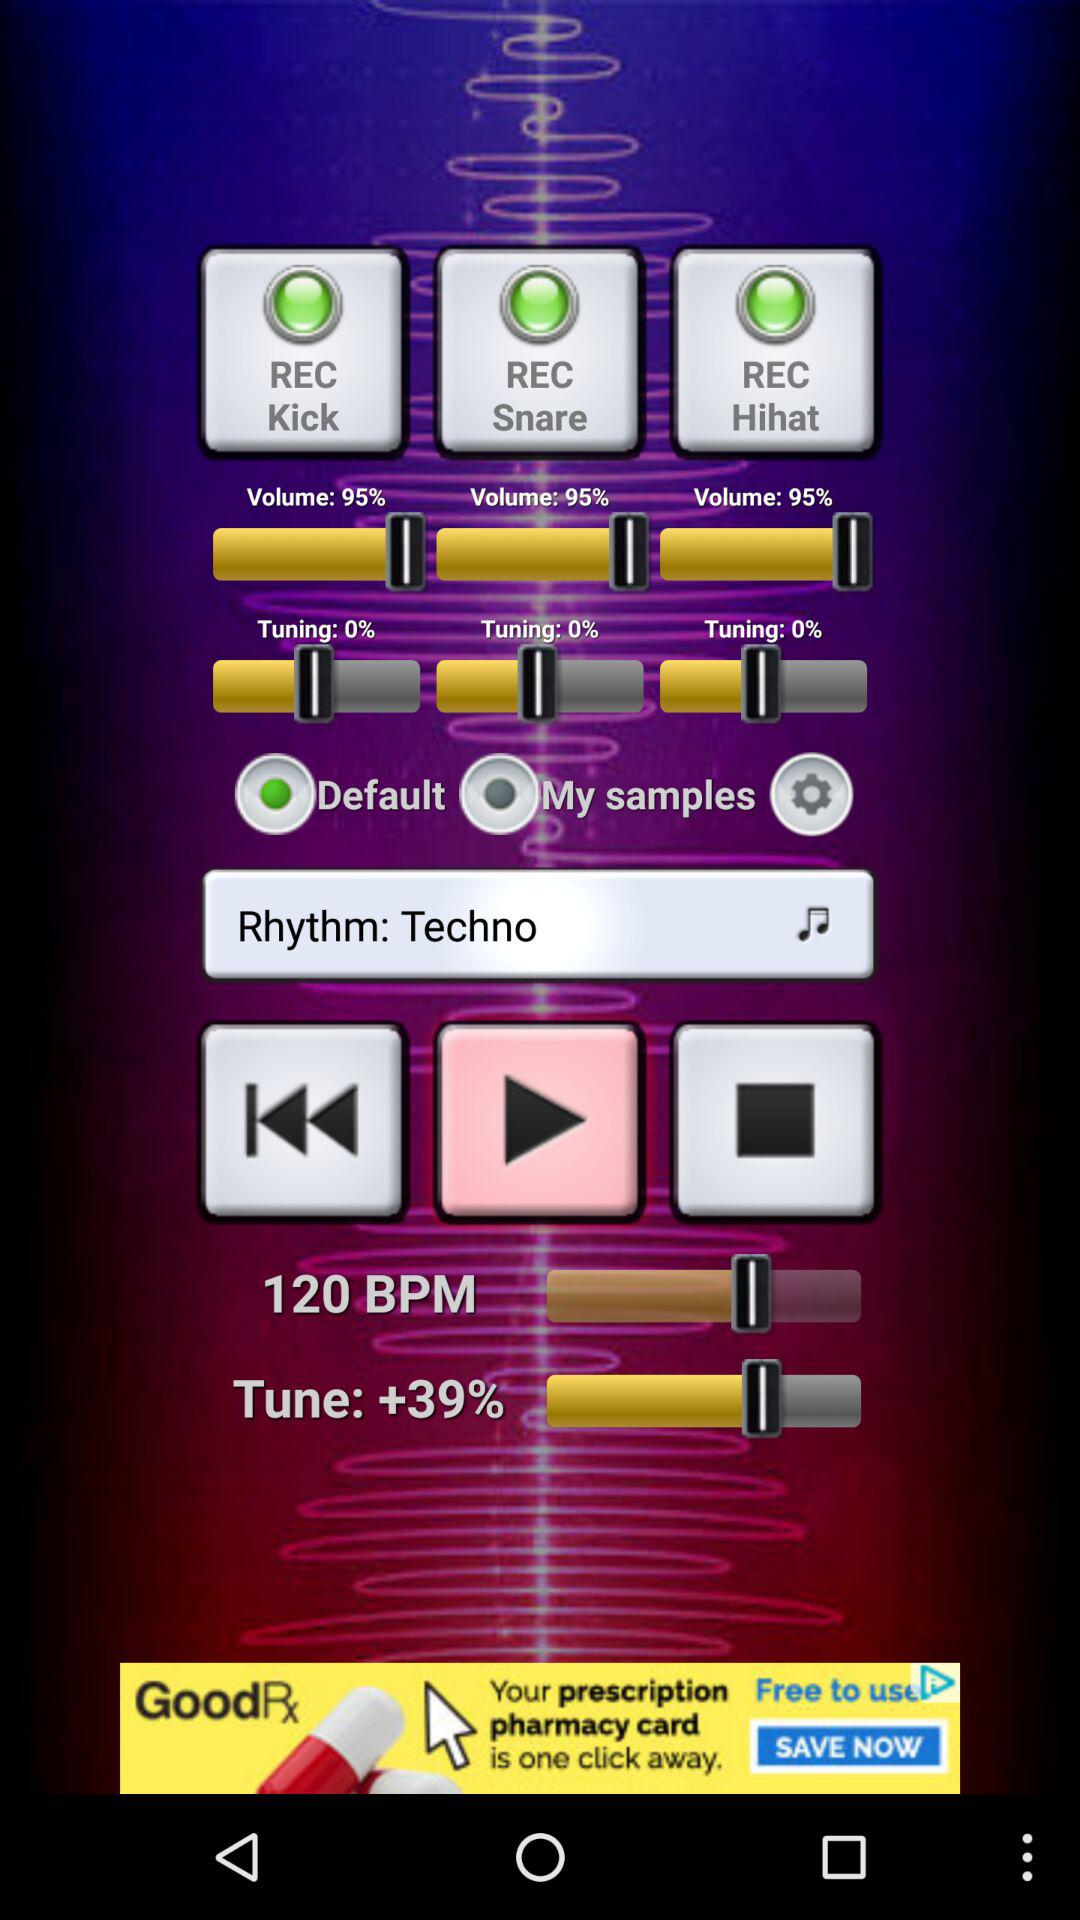What is the total volume of all three instruments?
Answer the question using a single word or phrase. 285% 